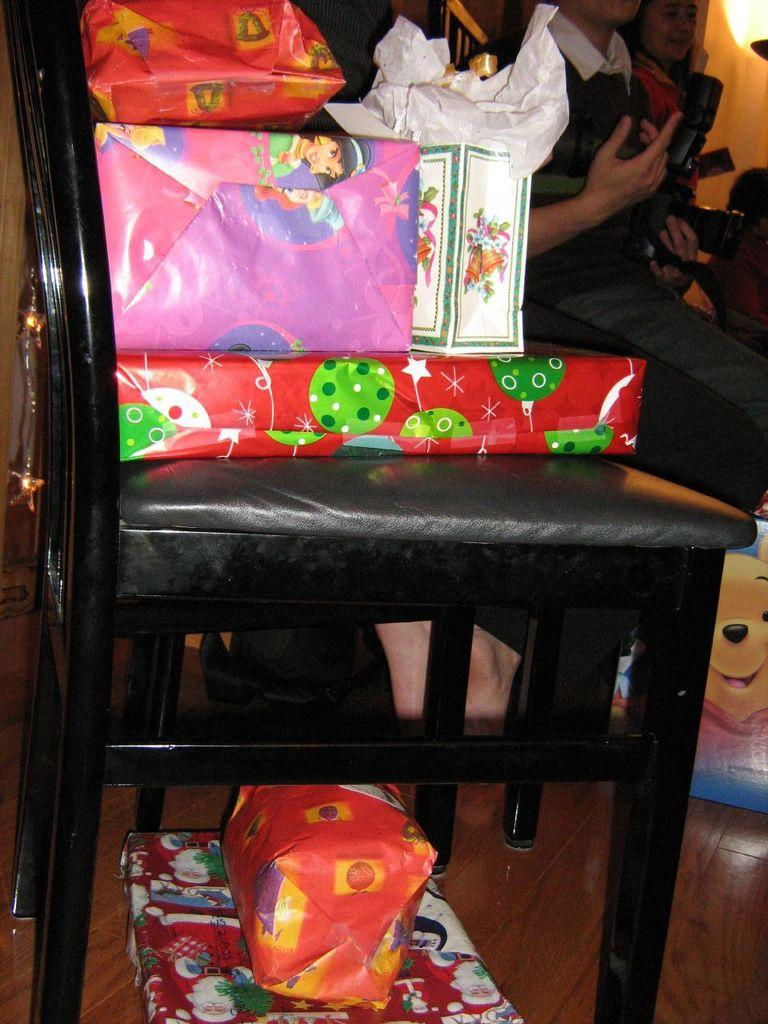What object can be seen in the image that people typically sit on? There is a chair in the image that people typically sit on. What is placed on the chair? Gift packets are on the chair. Can you describe the people in the background of the image? There are two persons sitting in the background. Are there any additional gift packets visible in the image? Yes, there are two more gift packets at the bottom of the image. What type of fuel is being used by the basin in the image? There is no basin present in the image, and therefore no fuel can be associated with it. 